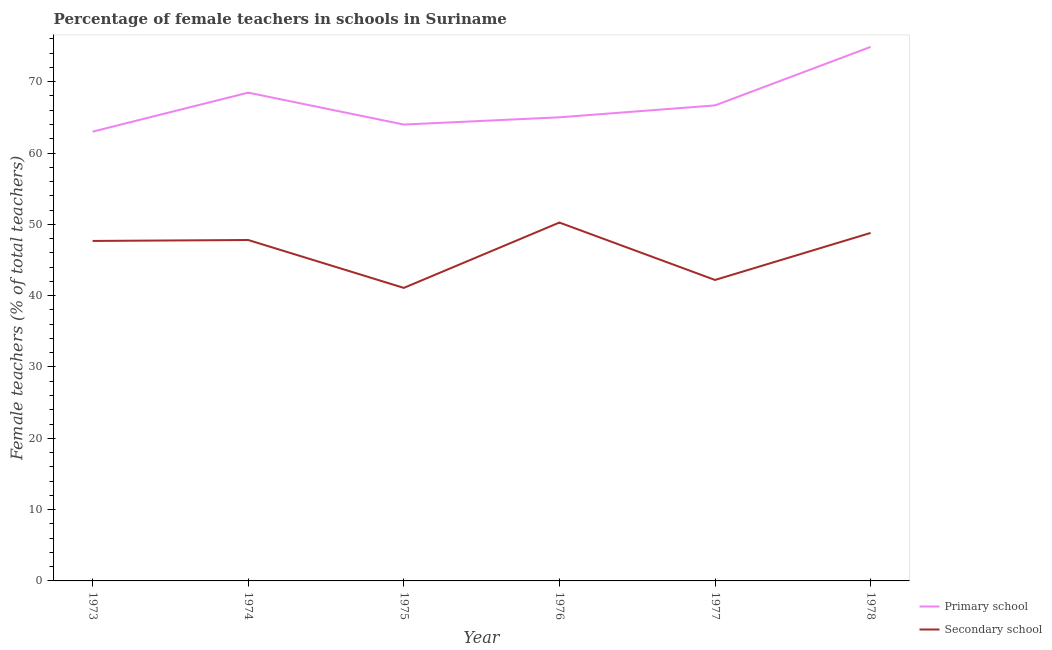Is the number of lines equal to the number of legend labels?
Your answer should be very brief. Yes. What is the percentage of female teachers in primary schools in 1975?
Your answer should be very brief. 63.99. Across all years, what is the maximum percentage of female teachers in secondary schools?
Give a very brief answer. 50.25. Across all years, what is the minimum percentage of female teachers in primary schools?
Provide a short and direct response. 63. In which year was the percentage of female teachers in secondary schools maximum?
Your answer should be very brief. 1976. In which year was the percentage of female teachers in secondary schools minimum?
Make the answer very short. 1975. What is the total percentage of female teachers in secondary schools in the graph?
Your answer should be very brief. 277.81. What is the difference between the percentage of female teachers in secondary schools in 1973 and that in 1975?
Your response must be concise. 6.58. What is the difference between the percentage of female teachers in secondary schools in 1978 and the percentage of female teachers in primary schools in 1974?
Your answer should be compact. -19.67. What is the average percentage of female teachers in primary schools per year?
Offer a terse response. 67. In the year 1975, what is the difference between the percentage of female teachers in secondary schools and percentage of female teachers in primary schools?
Offer a terse response. -22.9. In how many years, is the percentage of female teachers in secondary schools greater than 60 %?
Make the answer very short. 0. What is the ratio of the percentage of female teachers in secondary schools in 1975 to that in 1977?
Make the answer very short. 0.97. What is the difference between the highest and the second highest percentage of female teachers in secondary schools?
Your response must be concise. 1.46. What is the difference between the highest and the lowest percentage of female teachers in secondary schools?
Offer a terse response. 9.16. In how many years, is the percentage of female teachers in secondary schools greater than the average percentage of female teachers in secondary schools taken over all years?
Make the answer very short. 4. How many lines are there?
Provide a succinct answer. 2. Are the values on the major ticks of Y-axis written in scientific E-notation?
Offer a very short reply. No. Where does the legend appear in the graph?
Offer a very short reply. Bottom right. What is the title of the graph?
Provide a succinct answer. Percentage of female teachers in schools in Suriname. Does "Commercial service imports" appear as one of the legend labels in the graph?
Your response must be concise. No. What is the label or title of the Y-axis?
Offer a very short reply. Female teachers (% of total teachers). What is the Female teachers (% of total teachers) of Primary school in 1973?
Ensure brevity in your answer.  63. What is the Female teachers (% of total teachers) in Secondary school in 1973?
Your response must be concise. 47.67. What is the Female teachers (% of total teachers) of Primary school in 1974?
Give a very brief answer. 68.47. What is the Female teachers (% of total teachers) in Secondary school in 1974?
Ensure brevity in your answer.  47.8. What is the Female teachers (% of total teachers) in Primary school in 1975?
Offer a terse response. 63.99. What is the Female teachers (% of total teachers) in Secondary school in 1975?
Offer a terse response. 41.09. What is the Female teachers (% of total teachers) in Primary school in 1976?
Give a very brief answer. 65.01. What is the Female teachers (% of total teachers) in Secondary school in 1976?
Offer a very short reply. 50.25. What is the Female teachers (% of total teachers) of Primary school in 1977?
Your answer should be compact. 66.68. What is the Female teachers (% of total teachers) of Secondary school in 1977?
Give a very brief answer. 42.2. What is the Female teachers (% of total teachers) of Primary school in 1978?
Give a very brief answer. 74.88. What is the Female teachers (% of total teachers) of Secondary school in 1978?
Provide a succinct answer. 48.8. Across all years, what is the maximum Female teachers (% of total teachers) in Primary school?
Ensure brevity in your answer.  74.88. Across all years, what is the maximum Female teachers (% of total teachers) of Secondary school?
Your response must be concise. 50.25. Across all years, what is the minimum Female teachers (% of total teachers) in Primary school?
Make the answer very short. 63. Across all years, what is the minimum Female teachers (% of total teachers) of Secondary school?
Keep it short and to the point. 41.09. What is the total Female teachers (% of total teachers) of Primary school in the graph?
Your answer should be very brief. 402.02. What is the total Female teachers (% of total teachers) in Secondary school in the graph?
Keep it short and to the point. 277.81. What is the difference between the Female teachers (% of total teachers) of Primary school in 1973 and that in 1974?
Make the answer very short. -5.47. What is the difference between the Female teachers (% of total teachers) of Secondary school in 1973 and that in 1974?
Provide a short and direct response. -0.13. What is the difference between the Female teachers (% of total teachers) of Primary school in 1973 and that in 1975?
Offer a terse response. -1. What is the difference between the Female teachers (% of total teachers) of Secondary school in 1973 and that in 1975?
Give a very brief answer. 6.58. What is the difference between the Female teachers (% of total teachers) in Primary school in 1973 and that in 1976?
Provide a succinct answer. -2.01. What is the difference between the Female teachers (% of total teachers) in Secondary school in 1973 and that in 1976?
Your response must be concise. -2.58. What is the difference between the Female teachers (% of total teachers) in Primary school in 1973 and that in 1977?
Provide a succinct answer. -3.68. What is the difference between the Female teachers (% of total teachers) in Secondary school in 1973 and that in 1977?
Make the answer very short. 5.47. What is the difference between the Female teachers (% of total teachers) in Primary school in 1973 and that in 1978?
Give a very brief answer. -11.88. What is the difference between the Female teachers (% of total teachers) of Secondary school in 1973 and that in 1978?
Your answer should be very brief. -1.12. What is the difference between the Female teachers (% of total teachers) in Primary school in 1974 and that in 1975?
Your answer should be compact. 4.48. What is the difference between the Female teachers (% of total teachers) in Secondary school in 1974 and that in 1975?
Keep it short and to the point. 6.71. What is the difference between the Female teachers (% of total teachers) of Primary school in 1974 and that in 1976?
Ensure brevity in your answer.  3.46. What is the difference between the Female teachers (% of total teachers) in Secondary school in 1974 and that in 1976?
Your answer should be very brief. -2.45. What is the difference between the Female teachers (% of total teachers) in Primary school in 1974 and that in 1977?
Your response must be concise. 1.79. What is the difference between the Female teachers (% of total teachers) of Secondary school in 1974 and that in 1977?
Offer a very short reply. 5.6. What is the difference between the Female teachers (% of total teachers) in Primary school in 1974 and that in 1978?
Provide a short and direct response. -6.41. What is the difference between the Female teachers (% of total teachers) of Secondary school in 1974 and that in 1978?
Give a very brief answer. -0.99. What is the difference between the Female teachers (% of total teachers) of Primary school in 1975 and that in 1976?
Ensure brevity in your answer.  -1.01. What is the difference between the Female teachers (% of total teachers) of Secondary school in 1975 and that in 1976?
Offer a terse response. -9.16. What is the difference between the Female teachers (% of total teachers) in Primary school in 1975 and that in 1977?
Provide a short and direct response. -2.68. What is the difference between the Female teachers (% of total teachers) in Secondary school in 1975 and that in 1977?
Provide a succinct answer. -1.11. What is the difference between the Female teachers (% of total teachers) of Primary school in 1975 and that in 1978?
Your response must be concise. -10.88. What is the difference between the Female teachers (% of total teachers) of Secondary school in 1975 and that in 1978?
Offer a very short reply. -7.71. What is the difference between the Female teachers (% of total teachers) in Primary school in 1976 and that in 1977?
Offer a terse response. -1.67. What is the difference between the Female teachers (% of total teachers) in Secondary school in 1976 and that in 1977?
Provide a succinct answer. 8.05. What is the difference between the Female teachers (% of total teachers) in Primary school in 1976 and that in 1978?
Make the answer very short. -9.87. What is the difference between the Female teachers (% of total teachers) of Secondary school in 1976 and that in 1978?
Provide a succinct answer. 1.46. What is the difference between the Female teachers (% of total teachers) of Primary school in 1977 and that in 1978?
Provide a short and direct response. -8.2. What is the difference between the Female teachers (% of total teachers) of Secondary school in 1977 and that in 1978?
Make the answer very short. -6.59. What is the difference between the Female teachers (% of total teachers) of Primary school in 1973 and the Female teachers (% of total teachers) of Secondary school in 1974?
Make the answer very short. 15.19. What is the difference between the Female teachers (% of total teachers) of Primary school in 1973 and the Female teachers (% of total teachers) of Secondary school in 1975?
Provide a succinct answer. 21.91. What is the difference between the Female teachers (% of total teachers) of Primary school in 1973 and the Female teachers (% of total teachers) of Secondary school in 1976?
Offer a terse response. 12.75. What is the difference between the Female teachers (% of total teachers) of Primary school in 1973 and the Female teachers (% of total teachers) of Secondary school in 1977?
Your response must be concise. 20.8. What is the difference between the Female teachers (% of total teachers) of Primary school in 1973 and the Female teachers (% of total teachers) of Secondary school in 1978?
Provide a succinct answer. 14.2. What is the difference between the Female teachers (% of total teachers) of Primary school in 1974 and the Female teachers (% of total teachers) of Secondary school in 1975?
Your answer should be compact. 27.38. What is the difference between the Female teachers (% of total teachers) in Primary school in 1974 and the Female teachers (% of total teachers) in Secondary school in 1976?
Provide a succinct answer. 18.22. What is the difference between the Female teachers (% of total teachers) in Primary school in 1974 and the Female teachers (% of total teachers) in Secondary school in 1977?
Your response must be concise. 26.27. What is the difference between the Female teachers (% of total teachers) of Primary school in 1974 and the Female teachers (% of total teachers) of Secondary school in 1978?
Your answer should be compact. 19.67. What is the difference between the Female teachers (% of total teachers) of Primary school in 1975 and the Female teachers (% of total teachers) of Secondary school in 1976?
Your response must be concise. 13.74. What is the difference between the Female teachers (% of total teachers) of Primary school in 1975 and the Female teachers (% of total teachers) of Secondary school in 1977?
Provide a short and direct response. 21.79. What is the difference between the Female teachers (% of total teachers) of Primary school in 1975 and the Female teachers (% of total teachers) of Secondary school in 1978?
Offer a terse response. 15.2. What is the difference between the Female teachers (% of total teachers) in Primary school in 1976 and the Female teachers (% of total teachers) in Secondary school in 1977?
Your response must be concise. 22.81. What is the difference between the Female teachers (% of total teachers) in Primary school in 1976 and the Female teachers (% of total teachers) in Secondary school in 1978?
Make the answer very short. 16.21. What is the difference between the Female teachers (% of total teachers) of Primary school in 1977 and the Female teachers (% of total teachers) of Secondary school in 1978?
Give a very brief answer. 17.88. What is the average Female teachers (% of total teachers) in Primary school per year?
Ensure brevity in your answer.  67. What is the average Female teachers (% of total teachers) in Secondary school per year?
Ensure brevity in your answer.  46.3. In the year 1973, what is the difference between the Female teachers (% of total teachers) in Primary school and Female teachers (% of total teachers) in Secondary school?
Offer a terse response. 15.32. In the year 1974, what is the difference between the Female teachers (% of total teachers) of Primary school and Female teachers (% of total teachers) of Secondary school?
Ensure brevity in your answer.  20.66. In the year 1975, what is the difference between the Female teachers (% of total teachers) in Primary school and Female teachers (% of total teachers) in Secondary school?
Offer a very short reply. 22.9. In the year 1976, what is the difference between the Female teachers (% of total teachers) of Primary school and Female teachers (% of total teachers) of Secondary school?
Your response must be concise. 14.76. In the year 1977, what is the difference between the Female teachers (% of total teachers) of Primary school and Female teachers (% of total teachers) of Secondary school?
Your response must be concise. 24.48. In the year 1978, what is the difference between the Female teachers (% of total teachers) in Primary school and Female teachers (% of total teachers) in Secondary school?
Keep it short and to the point. 26.08. What is the ratio of the Female teachers (% of total teachers) of Primary school in 1973 to that in 1974?
Provide a succinct answer. 0.92. What is the ratio of the Female teachers (% of total teachers) in Secondary school in 1973 to that in 1974?
Your answer should be very brief. 1. What is the ratio of the Female teachers (% of total teachers) of Primary school in 1973 to that in 1975?
Your response must be concise. 0.98. What is the ratio of the Female teachers (% of total teachers) of Secondary school in 1973 to that in 1975?
Provide a short and direct response. 1.16. What is the ratio of the Female teachers (% of total teachers) of Primary school in 1973 to that in 1976?
Offer a very short reply. 0.97. What is the ratio of the Female teachers (% of total teachers) in Secondary school in 1973 to that in 1976?
Keep it short and to the point. 0.95. What is the ratio of the Female teachers (% of total teachers) in Primary school in 1973 to that in 1977?
Make the answer very short. 0.94. What is the ratio of the Female teachers (% of total teachers) of Secondary school in 1973 to that in 1977?
Give a very brief answer. 1.13. What is the ratio of the Female teachers (% of total teachers) of Primary school in 1973 to that in 1978?
Your answer should be compact. 0.84. What is the ratio of the Female teachers (% of total teachers) in Primary school in 1974 to that in 1975?
Provide a short and direct response. 1.07. What is the ratio of the Female teachers (% of total teachers) in Secondary school in 1974 to that in 1975?
Your answer should be very brief. 1.16. What is the ratio of the Female teachers (% of total teachers) in Primary school in 1974 to that in 1976?
Provide a succinct answer. 1.05. What is the ratio of the Female teachers (% of total teachers) in Secondary school in 1974 to that in 1976?
Keep it short and to the point. 0.95. What is the ratio of the Female teachers (% of total teachers) of Primary school in 1974 to that in 1977?
Offer a very short reply. 1.03. What is the ratio of the Female teachers (% of total teachers) of Secondary school in 1974 to that in 1977?
Provide a succinct answer. 1.13. What is the ratio of the Female teachers (% of total teachers) of Primary school in 1974 to that in 1978?
Provide a succinct answer. 0.91. What is the ratio of the Female teachers (% of total teachers) in Secondary school in 1974 to that in 1978?
Provide a succinct answer. 0.98. What is the ratio of the Female teachers (% of total teachers) of Primary school in 1975 to that in 1976?
Give a very brief answer. 0.98. What is the ratio of the Female teachers (% of total teachers) of Secondary school in 1975 to that in 1976?
Your response must be concise. 0.82. What is the ratio of the Female teachers (% of total teachers) in Primary school in 1975 to that in 1977?
Offer a very short reply. 0.96. What is the ratio of the Female teachers (% of total teachers) of Secondary school in 1975 to that in 1977?
Give a very brief answer. 0.97. What is the ratio of the Female teachers (% of total teachers) in Primary school in 1975 to that in 1978?
Give a very brief answer. 0.85. What is the ratio of the Female teachers (% of total teachers) in Secondary school in 1975 to that in 1978?
Provide a short and direct response. 0.84. What is the ratio of the Female teachers (% of total teachers) of Secondary school in 1976 to that in 1977?
Keep it short and to the point. 1.19. What is the ratio of the Female teachers (% of total teachers) in Primary school in 1976 to that in 1978?
Keep it short and to the point. 0.87. What is the ratio of the Female teachers (% of total teachers) in Secondary school in 1976 to that in 1978?
Give a very brief answer. 1.03. What is the ratio of the Female teachers (% of total teachers) in Primary school in 1977 to that in 1978?
Your answer should be very brief. 0.89. What is the ratio of the Female teachers (% of total teachers) of Secondary school in 1977 to that in 1978?
Ensure brevity in your answer.  0.86. What is the difference between the highest and the second highest Female teachers (% of total teachers) in Primary school?
Offer a very short reply. 6.41. What is the difference between the highest and the second highest Female teachers (% of total teachers) of Secondary school?
Your answer should be compact. 1.46. What is the difference between the highest and the lowest Female teachers (% of total teachers) of Primary school?
Provide a succinct answer. 11.88. What is the difference between the highest and the lowest Female teachers (% of total teachers) in Secondary school?
Keep it short and to the point. 9.16. 